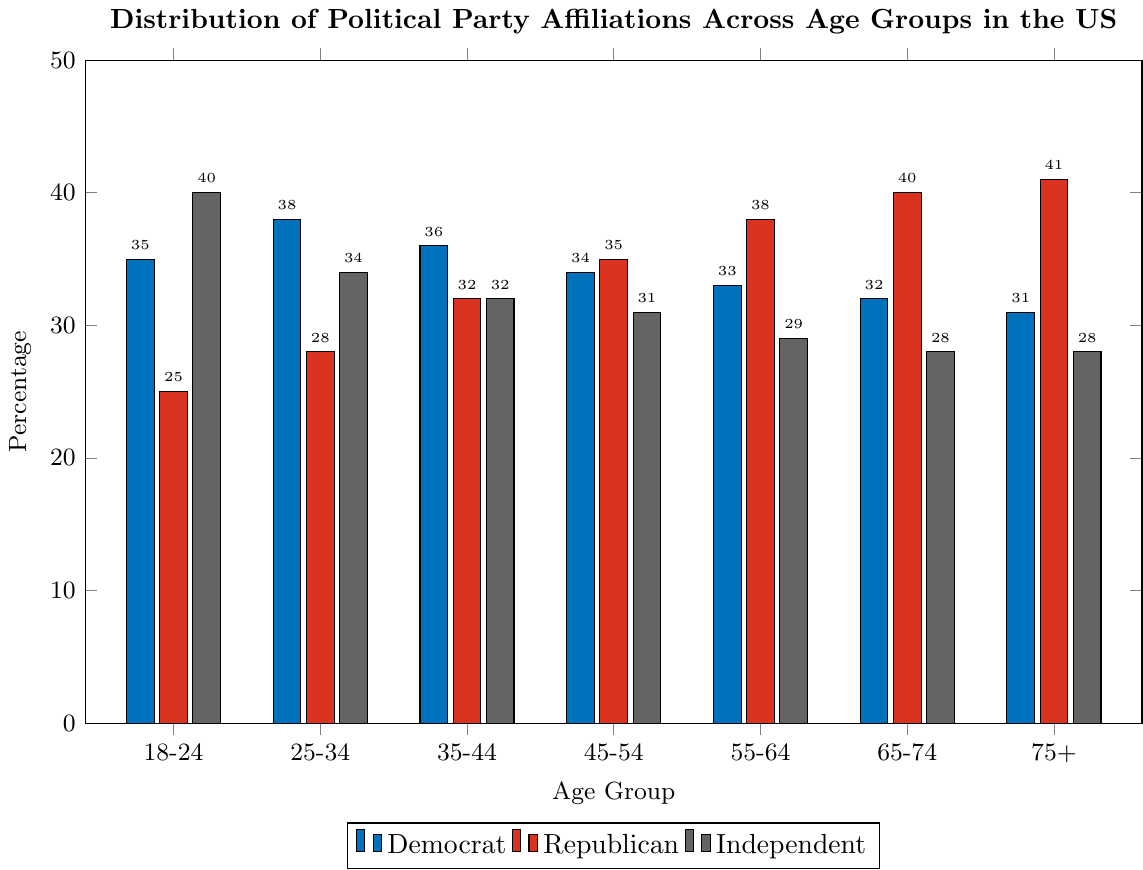What's the most popular political affiliation for the 18-24 age group? The bar for the Independent group is tallest for the 18-24 age group. By counting the height of the bars, Independent has the highest percentage.
Answer: Independent Which age group has the highest percentage of Republicans? Among the Republican bars, the 75+ age group bar is the tallest.
Answer: 75+ Compare the percentage of Democrats and Republicans in the 55-64 age group. Which is higher? The Democratic percentage for this age group is 33%, while the Republican percentage is 38%. The bar for Republicans is taller.
Answer: Republican What is the trend of Democratic affiliation from the youngest to the oldest age group? Observing the heights of the Democratic bars from left to right, we notice a decreasing trend. The percentage drops from 35% for the 18-24 age group, gradually decreasing to 31% for the 75+ age group.
Answer: Decreasing Add the percentages of Independents and Republicans for the 45-54 age group. What is the total? The percentages are 31% for Independents and 35% for Republicans. Adding these together: 31 + 35 = 66.
Answer: 66 How does the percentage of Democrats in the 25-34 age group compare to the 65-74 age group? For the 25-34 age group, the Democrat percentage is 38%. For the 65-74 age group, it is 32%. Comparing these values, 38% is higher than 32%.
Answer: 25-34 has a higher percentage Which group shows a clear decline in percentages as the age increases? The Independent group's bars decrease consistently from 40% in the 18-24 age group to 28% in the 75+ age group.
Answer: Independent What percentage difference is there between Democrats and Republicans in the 35-44 age group? Democrats have 36% and Republicans have 32% in the 35-44 age group. The difference is 36 - 32 = 4%.
Answer: 4% What's the average percentage of Independents across all age groups? The percentages are: 40, 34, 32, 31, 29, 28, 28. Summing these: 40 + 34 + 32 + 31 + 29 + 28 + 28 = 222. There are 7 age groups, so the average is 222 / 7 ≈ 31.71%.
Answer: 31.71 